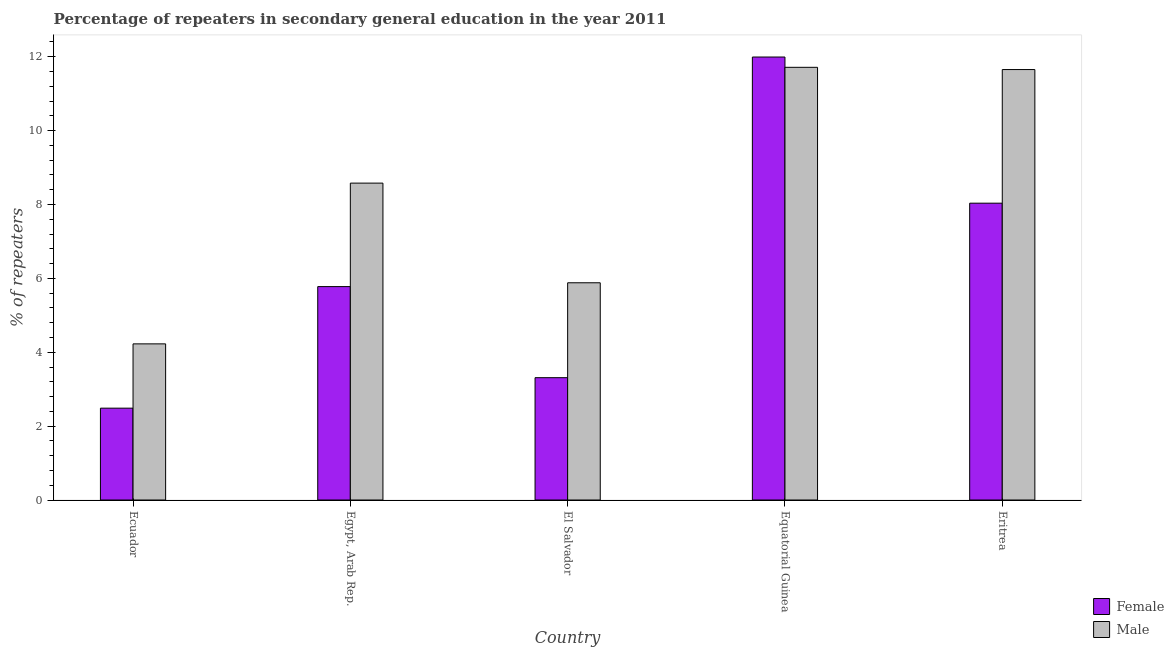How many groups of bars are there?
Make the answer very short. 5. Are the number of bars on each tick of the X-axis equal?
Offer a terse response. Yes. How many bars are there on the 1st tick from the right?
Provide a short and direct response. 2. What is the label of the 3rd group of bars from the left?
Provide a succinct answer. El Salvador. What is the percentage of male repeaters in Ecuador?
Your response must be concise. 4.23. Across all countries, what is the maximum percentage of male repeaters?
Provide a succinct answer. 11.71. Across all countries, what is the minimum percentage of female repeaters?
Provide a short and direct response. 2.49. In which country was the percentage of male repeaters maximum?
Keep it short and to the point. Equatorial Guinea. In which country was the percentage of female repeaters minimum?
Keep it short and to the point. Ecuador. What is the total percentage of male repeaters in the graph?
Give a very brief answer. 42.05. What is the difference between the percentage of female repeaters in Egypt, Arab Rep. and that in Eritrea?
Provide a short and direct response. -2.26. What is the difference between the percentage of male repeaters in Egypt, Arab Rep. and the percentage of female repeaters in Eritrea?
Your answer should be compact. 0.54. What is the average percentage of male repeaters per country?
Ensure brevity in your answer.  8.41. What is the difference between the percentage of female repeaters and percentage of male repeaters in Equatorial Guinea?
Offer a terse response. 0.28. What is the ratio of the percentage of female repeaters in El Salvador to that in Equatorial Guinea?
Your answer should be compact. 0.28. Is the difference between the percentage of male repeaters in Egypt, Arab Rep. and El Salvador greater than the difference between the percentage of female repeaters in Egypt, Arab Rep. and El Salvador?
Your answer should be compact. Yes. What is the difference between the highest and the second highest percentage of male repeaters?
Offer a terse response. 0.06. What is the difference between the highest and the lowest percentage of male repeaters?
Give a very brief answer. 7.49. In how many countries, is the percentage of female repeaters greater than the average percentage of female repeaters taken over all countries?
Provide a succinct answer. 2. Is the sum of the percentage of female repeaters in Ecuador and Equatorial Guinea greater than the maximum percentage of male repeaters across all countries?
Your answer should be very brief. Yes. How many bars are there?
Ensure brevity in your answer.  10. How many countries are there in the graph?
Offer a very short reply. 5. What is the difference between two consecutive major ticks on the Y-axis?
Give a very brief answer. 2. Does the graph contain any zero values?
Your response must be concise. No. How many legend labels are there?
Your answer should be very brief. 2. What is the title of the graph?
Your answer should be very brief. Percentage of repeaters in secondary general education in the year 2011. What is the label or title of the Y-axis?
Keep it short and to the point. % of repeaters. What is the % of repeaters in Female in Ecuador?
Offer a very short reply. 2.49. What is the % of repeaters in Male in Ecuador?
Your answer should be compact. 4.23. What is the % of repeaters in Female in Egypt, Arab Rep.?
Provide a short and direct response. 5.78. What is the % of repeaters in Male in Egypt, Arab Rep.?
Give a very brief answer. 8.58. What is the % of repeaters of Female in El Salvador?
Ensure brevity in your answer.  3.31. What is the % of repeaters of Male in El Salvador?
Your answer should be compact. 5.88. What is the % of repeaters in Female in Equatorial Guinea?
Your response must be concise. 11.99. What is the % of repeaters in Male in Equatorial Guinea?
Offer a terse response. 11.71. What is the % of repeaters of Female in Eritrea?
Provide a succinct answer. 8.03. What is the % of repeaters in Male in Eritrea?
Offer a very short reply. 11.65. Across all countries, what is the maximum % of repeaters in Female?
Your answer should be very brief. 11.99. Across all countries, what is the maximum % of repeaters in Male?
Provide a short and direct response. 11.71. Across all countries, what is the minimum % of repeaters of Female?
Offer a very short reply. 2.49. Across all countries, what is the minimum % of repeaters of Male?
Keep it short and to the point. 4.23. What is the total % of repeaters of Female in the graph?
Provide a short and direct response. 31.6. What is the total % of repeaters in Male in the graph?
Keep it short and to the point. 42.05. What is the difference between the % of repeaters in Female in Ecuador and that in Egypt, Arab Rep.?
Give a very brief answer. -3.29. What is the difference between the % of repeaters of Male in Ecuador and that in Egypt, Arab Rep.?
Your answer should be compact. -4.35. What is the difference between the % of repeaters of Female in Ecuador and that in El Salvador?
Provide a succinct answer. -0.83. What is the difference between the % of repeaters in Male in Ecuador and that in El Salvador?
Offer a terse response. -1.65. What is the difference between the % of repeaters in Female in Ecuador and that in Equatorial Guinea?
Offer a very short reply. -9.5. What is the difference between the % of repeaters in Male in Ecuador and that in Equatorial Guinea?
Provide a short and direct response. -7.49. What is the difference between the % of repeaters in Female in Ecuador and that in Eritrea?
Your answer should be compact. -5.55. What is the difference between the % of repeaters of Male in Ecuador and that in Eritrea?
Offer a terse response. -7.42. What is the difference between the % of repeaters of Female in Egypt, Arab Rep. and that in El Salvador?
Make the answer very short. 2.47. What is the difference between the % of repeaters of Male in Egypt, Arab Rep. and that in El Salvador?
Your answer should be compact. 2.7. What is the difference between the % of repeaters of Female in Egypt, Arab Rep. and that in Equatorial Guinea?
Make the answer very short. -6.21. What is the difference between the % of repeaters in Male in Egypt, Arab Rep. and that in Equatorial Guinea?
Your answer should be compact. -3.13. What is the difference between the % of repeaters in Female in Egypt, Arab Rep. and that in Eritrea?
Offer a very short reply. -2.26. What is the difference between the % of repeaters of Male in Egypt, Arab Rep. and that in Eritrea?
Ensure brevity in your answer.  -3.07. What is the difference between the % of repeaters in Female in El Salvador and that in Equatorial Guinea?
Make the answer very short. -8.68. What is the difference between the % of repeaters of Male in El Salvador and that in Equatorial Guinea?
Your answer should be very brief. -5.83. What is the difference between the % of repeaters of Female in El Salvador and that in Eritrea?
Make the answer very short. -4.72. What is the difference between the % of repeaters in Male in El Salvador and that in Eritrea?
Ensure brevity in your answer.  -5.77. What is the difference between the % of repeaters of Female in Equatorial Guinea and that in Eritrea?
Provide a short and direct response. 3.96. What is the difference between the % of repeaters of Male in Equatorial Guinea and that in Eritrea?
Your answer should be compact. 0.06. What is the difference between the % of repeaters of Female in Ecuador and the % of repeaters of Male in Egypt, Arab Rep.?
Make the answer very short. -6.09. What is the difference between the % of repeaters of Female in Ecuador and the % of repeaters of Male in El Salvador?
Your response must be concise. -3.39. What is the difference between the % of repeaters of Female in Ecuador and the % of repeaters of Male in Equatorial Guinea?
Give a very brief answer. -9.23. What is the difference between the % of repeaters in Female in Ecuador and the % of repeaters in Male in Eritrea?
Your answer should be compact. -9.17. What is the difference between the % of repeaters of Female in Egypt, Arab Rep. and the % of repeaters of Male in El Salvador?
Offer a terse response. -0.1. What is the difference between the % of repeaters of Female in Egypt, Arab Rep. and the % of repeaters of Male in Equatorial Guinea?
Your answer should be very brief. -5.94. What is the difference between the % of repeaters of Female in Egypt, Arab Rep. and the % of repeaters of Male in Eritrea?
Provide a succinct answer. -5.88. What is the difference between the % of repeaters in Female in El Salvador and the % of repeaters in Male in Equatorial Guinea?
Offer a very short reply. -8.4. What is the difference between the % of repeaters of Female in El Salvador and the % of repeaters of Male in Eritrea?
Keep it short and to the point. -8.34. What is the difference between the % of repeaters in Female in Equatorial Guinea and the % of repeaters in Male in Eritrea?
Provide a short and direct response. 0.34. What is the average % of repeaters of Female per country?
Make the answer very short. 6.32. What is the average % of repeaters of Male per country?
Provide a short and direct response. 8.41. What is the difference between the % of repeaters in Female and % of repeaters in Male in Ecuador?
Offer a very short reply. -1.74. What is the difference between the % of repeaters in Female and % of repeaters in Male in Egypt, Arab Rep.?
Give a very brief answer. -2.8. What is the difference between the % of repeaters of Female and % of repeaters of Male in El Salvador?
Provide a succinct answer. -2.57. What is the difference between the % of repeaters of Female and % of repeaters of Male in Equatorial Guinea?
Your answer should be very brief. 0.28. What is the difference between the % of repeaters in Female and % of repeaters in Male in Eritrea?
Make the answer very short. -3.62. What is the ratio of the % of repeaters in Female in Ecuador to that in Egypt, Arab Rep.?
Your answer should be compact. 0.43. What is the ratio of the % of repeaters of Male in Ecuador to that in Egypt, Arab Rep.?
Provide a short and direct response. 0.49. What is the ratio of the % of repeaters of Female in Ecuador to that in El Salvador?
Your answer should be very brief. 0.75. What is the ratio of the % of repeaters in Male in Ecuador to that in El Salvador?
Your answer should be very brief. 0.72. What is the ratio of the % of repeaters in Female in Ecuador to that in Equatorial Guinea?
Give a very brief answer. 0.21. What is the ratio of the % of repeaters in Male in Ecuador to that in Equatorial Guinea?
Offer a terse response. 0.36. What is the ratio of the % of repeaters in Female in Ecuador to that in Eritrea?
Your response must be concise. 0.31. What is the ratio of the % of repeaters in Male in Ecuador to that in Eritrea?
Provide a succinct answer. 0.36. What is the ratio of the % of repeaters of Female in Egypt, Arab Rep. to that in El Salvador?
Your answer should be very brief. 1.74. What is the ratio of the % of repeaters in Male in Egypt, Arab Rep. to that in El Salvador?
Your answer should be compact. 1.46. What is the ratio of the % of repeaters of Female in Egypt, Arab Rep. to that in Equatorial Guinea?
Your answer should be very brief. 0.48. What is the ratio of the % of repeaters in Male in Egypt, Arab Rep. to that in Equatorial Guinea?
Your answer should be very brief. 0.73. What is the ratio of the % of repeaters of Female in Egypt, Arab Rep. to that in Eritrea?
Offer a terse response. 0.72. What is the ratio of the % of repeaters in Male in Egypt, Arab Rep. to that in Eritrea?
Your answer should be compact. 0.74. What is the ratio of the % of repeaters of Female in El Salvador to that in Equatorial Guinea?
Your answer should be very brief. 0.28. What is the ratio of the % of repeaters of Male in El Salvador to that in Equatorial Guinea?
Offer a very short reply. 0.5. What is the ratio of the % of repeaters in Female in El Salvador to that in Eritrea?
Ensure brevity in your answer.  0.41. What is the ratio of the % of repeaters of Male in El Salvador to that in Eritrea?
Keep it short and to the point. 0.5. What is the ratio of the % of repeaters of Female in Equatorial Guinea to that in Eritrea?
Offer a terse response. 1.49. What is the difference between the highest and the second highest % of repeaters of Female?
Your answer should be very brief. 3.96. What is the difference between the highest and the second highest % of repeaters of Male?
Your answer should be very brief. 0.06. What is the difference between the highest and the lowest % of repeaters of Female?
Keep it short and to the point. 9.5. What is the difference between the highest and the lowest % of repeaters in Male?
Make the answer very short. 7.49. 